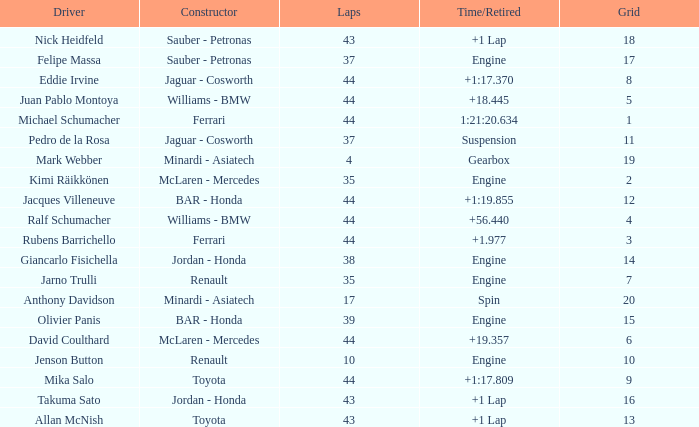What was the fewest laps for somone who finished +18.445? 44.0. 